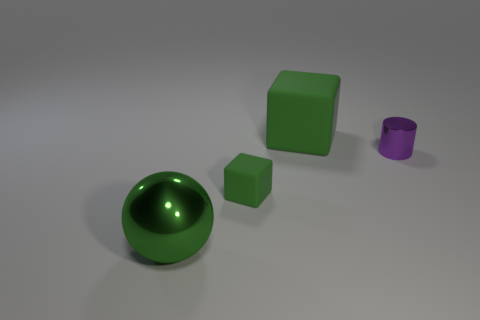There is another rubber thing that is the same shape as the large green rubber thing; what color is it?
Make the answer very short. Green. How many large objects are both behind the green metallic sphere and in front of the small block?
Your answer should be compact. 0. Are there more green balls on the right side of the small purple metallic object than balls behind the tiny green matte block?
Your answer should be compact. No. The green metal ball has what size?
Offer a terse response. Large. Is there a purple metallic object of the same shape as the small green matte thing?
Provide a succinct answer. No. There is a small purple thing; does it have the same shape as the rubber object behind the tiny matte cube?
Offer a terse response. No. What is the size of the thing that is in front of the tiny metal cylinder and behind the big ball?
Your response must be concise. Small. How many blocks are there?
Offer a terse response. 2. What is the material of the cube that is the same size as the purple shiny cylinder?
Ensure brevity in your answer.  Rubber. Are there any green shiny things of the same size as the metallic cylinder?
Your answer should be very brief. No. 